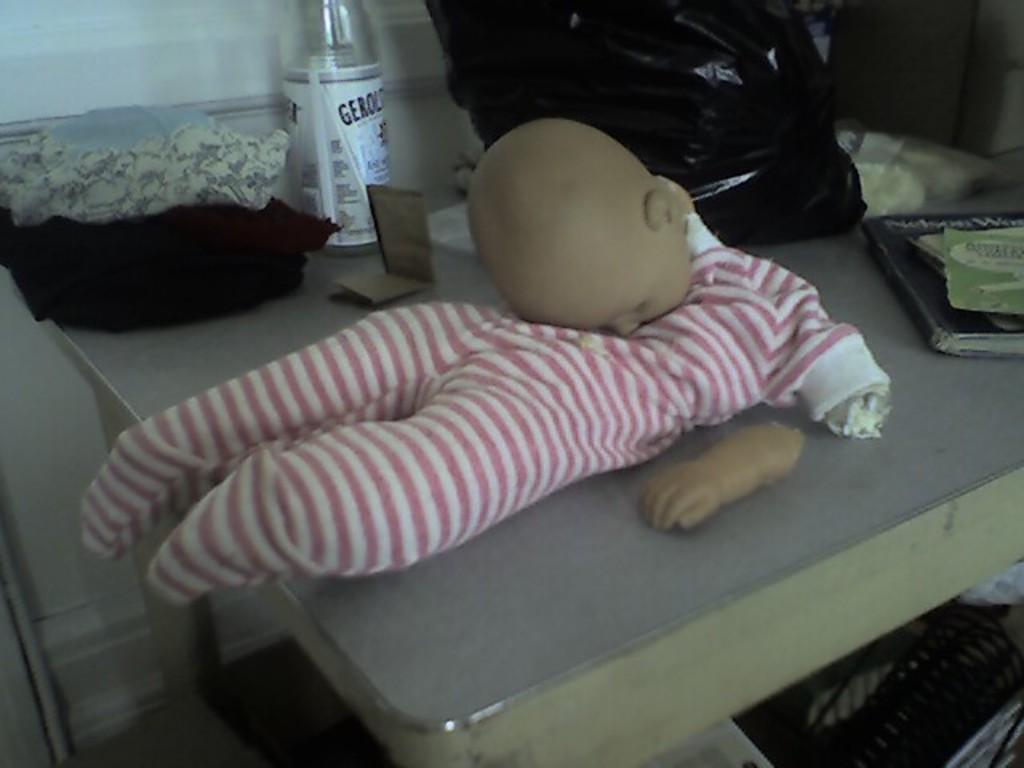In one or two sentences, can you explain what this image depicts? This picture contains a grey table on which a doll in pink dress is placed hand on table, we even see black cloth, water bottle and black plastic cover and books are placed on it. 